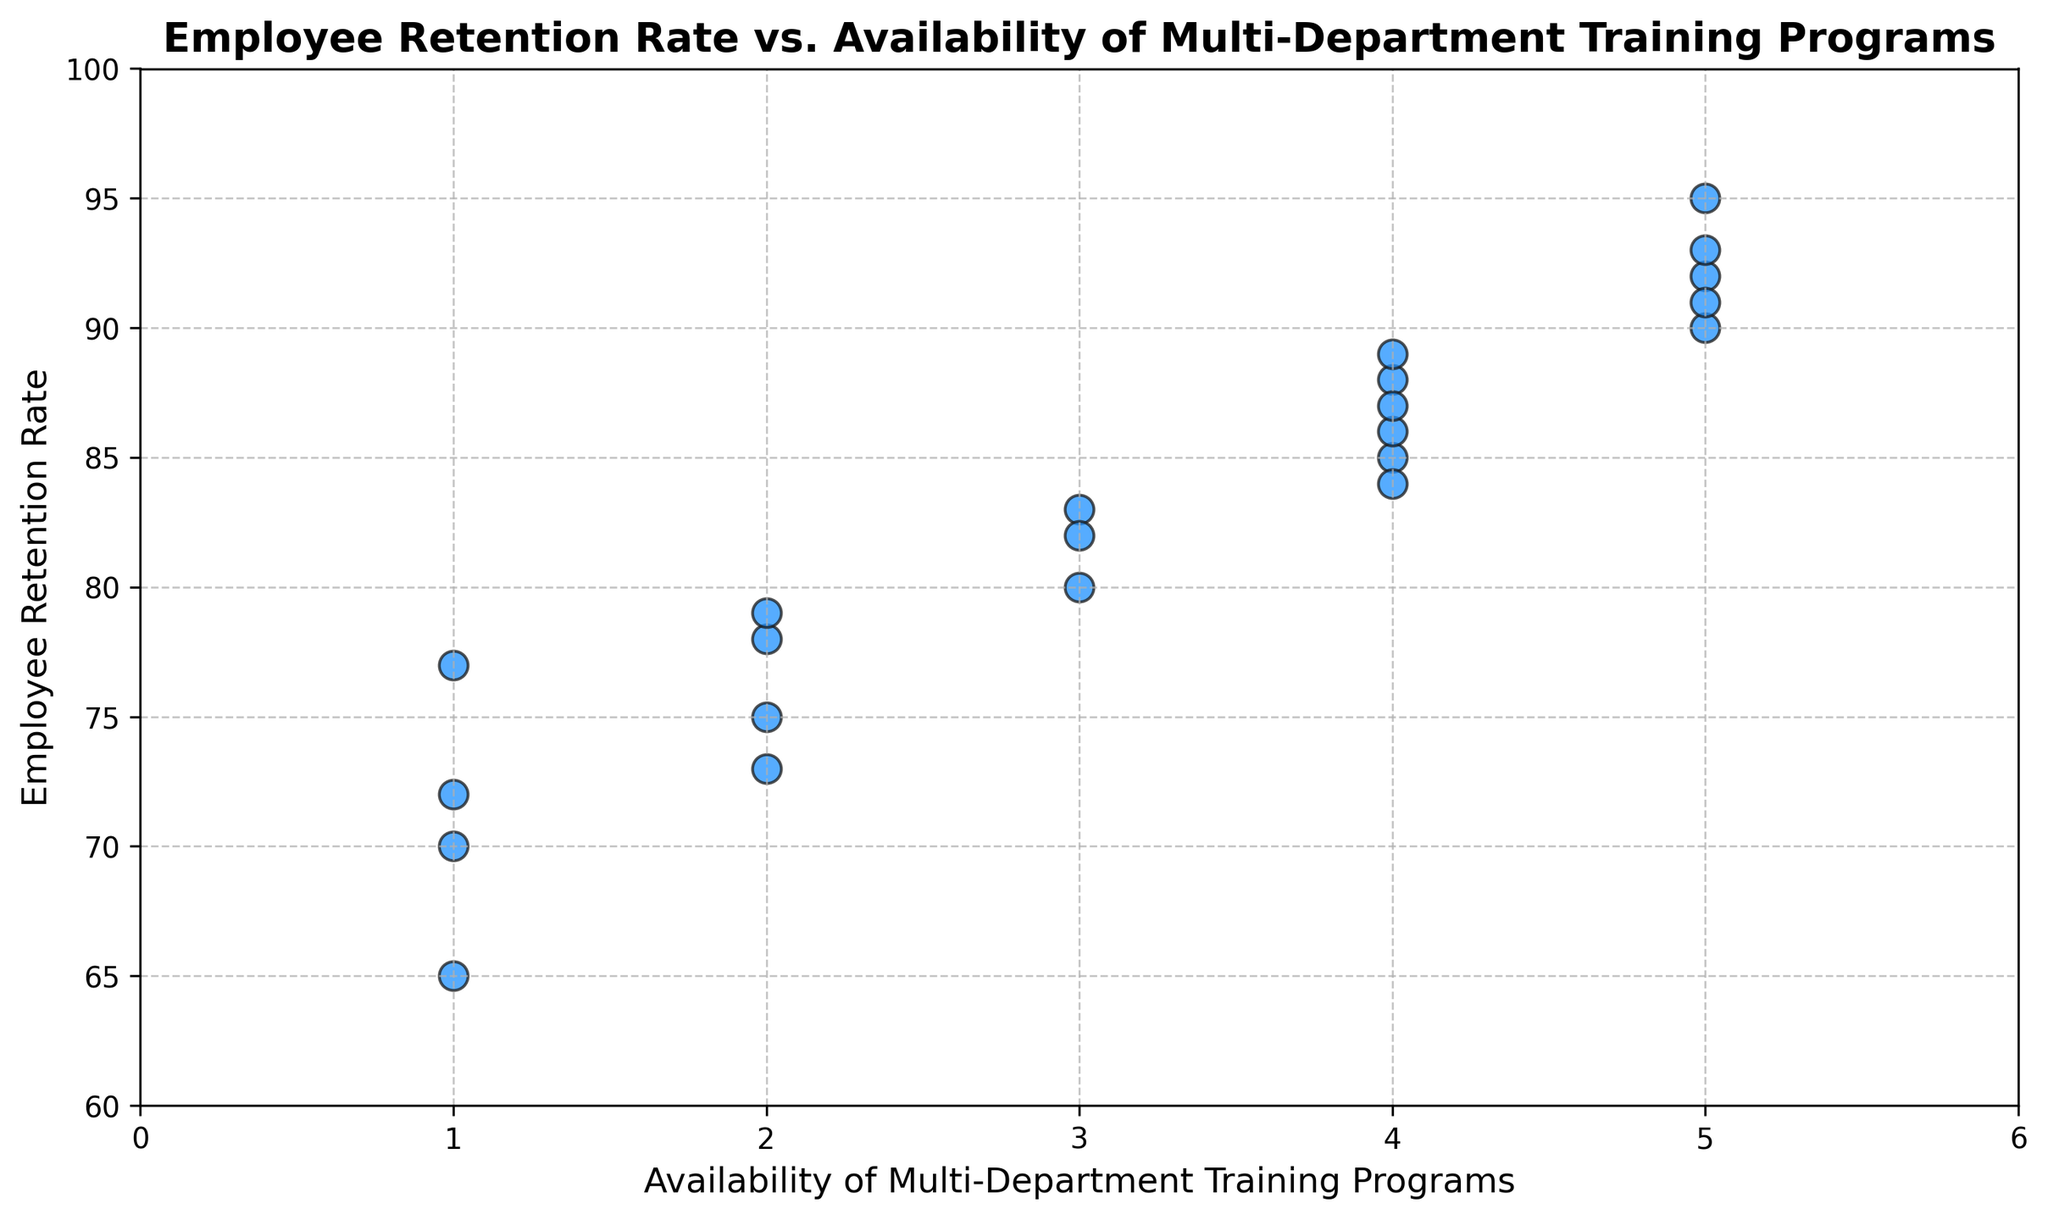What's the highest Employee Retention Rate observed in the figure? By observing the scatter plot, the highest point on the y-axis represents the highest Employee Retention Rate. The highest point shows a rate of 95.
Answer: 95 Which data point corresponds to an Employer Retention Rate of 70? To find this, locate the point where the y-value is 70. The x-value at that point shows the Availability of Multi-Department Training Programs, which is 1.
Answer: 1 Is there a trend between Employee Retention Rate and the Availability of Multi-Department Training Programs? By observing the scatter plot, one can notice that as the Availability of Multi-Department Training Programs increases, the Employee Retention Rate also tends to increase. This suggests a positive correlation.
Answer: Yes, positive correlation What is the average Employee Retention Rate for organizations with 4 Multi-Department Training Programs? Identify the points on the x-axis where the value is 4. The corresponding y-values are 85, 88, 84, and 89. Calculate the average of these values: (85 + 88 + 84 + 89) / 4 = 86.5
Answer: 86.5 How many organizations have an Employee Retention Rate of at least 90? Locate all points where the y-value is 90 or higher. The corresponding points are 92, 95, 90, 93, and 91, which makes it 5 organizations.
Answer: 5 Which training program level shows the least variability in Employee Retention Rate? Observe the scatter plot and find the training program level where the points are the closest to each other vertically. The level with the least vertical spread is 5.
Answer: 5 What is the range of Employee Retention Rates for organizations with 3 Multi-Department Training Programs? Identify the points where the x-value is 3. The corresponding y-values are 80, 83, and 82. The range is calculated as the highest value minus the lowest value: 83 - 80 = 3.
Answer: 3 Does any organization with 1 Multi-Department Training Program have higher than 80% retention rate? Find the points where the x-value is 1 on the scatter plot and check if any have a y-value greater than 80. All y-values for x=1 are 70 and 77, meaning they are below 80.
Answer: No What is the Employee Retention Rate for the organization with the highest Availability of Multi-Department Training Programs? Identify the point with the highest x-value of 5, corresponding to the highest y-values. The y-values for x=5 are 92, 90, 95, and 93. The highest retention rate among these is 95.
Answer: 95 Compare the Employee Retention Rates between organizations with 2 and 3 Multi-Department Training Programs. Locate the points where x-values are 2 and 3. The y-values for x=2 are 78, 73, and 75. The y-values for x=3 are 80, 83, and 82. Calculate the averages: (78+73+75)/3 = 75.33 and (80+83+82)/3 = 81.67. Compare these averages. Organizations with 3 programs have a higher average retention rate.
Answer: 3 > 2 